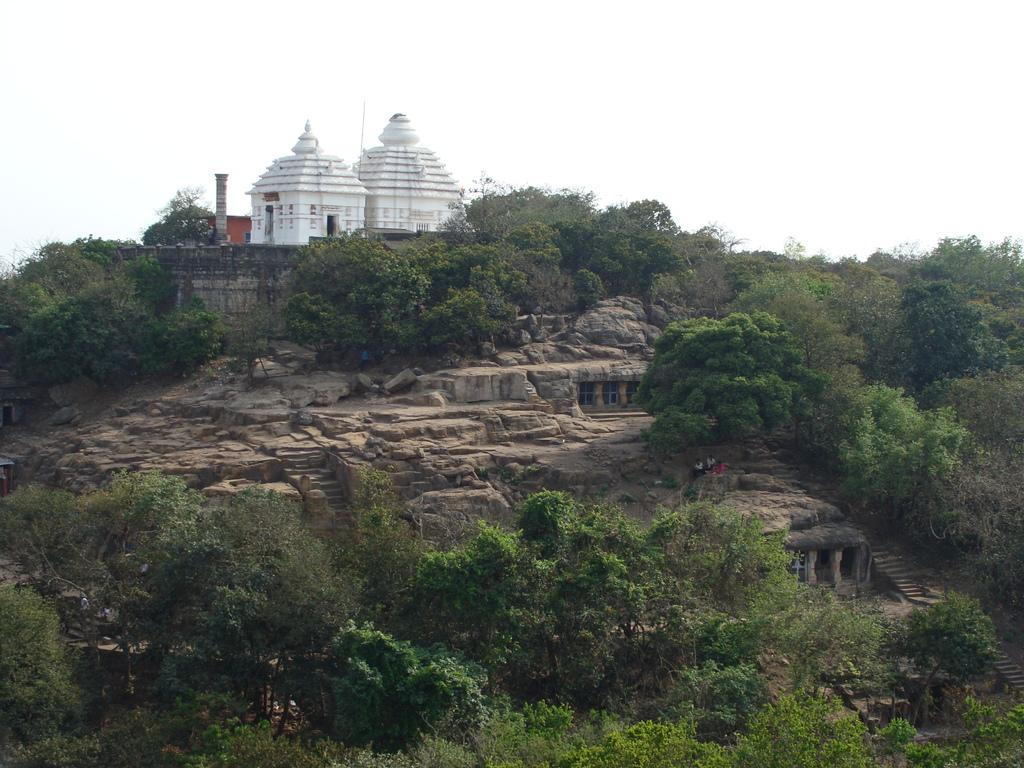What type of structure is in the image? There is a temple in the image. Where is the temple situated? The temple is located on a hill. What can be seen in the background of the image? There is sky visible in the background of the image. How many dogs are playing with a box in the image? There are no dogs or boxes present in the image; it features a temple located on a hill with sky visible in the background. 